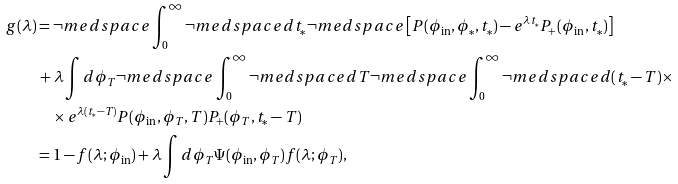<formula> <loc_0><loc_0><loc_500><loc_500>g ( \lambda ) & = \neg m e d s p a c e \int _ { 0 } ^ { \infty } \neg m e d s p a c e d t _ { * } \neg m e d s p a c e \left [ P ( \phi _ { \text {in} } , \phi _ { * } , t _ { * } ) - e ^ { \lambda t _ { * } } P _ { + } ( \phi _ { \text {in} } , t _ { * } ) \right ] \\ & \, + \lambda \int d \phi _ { T } \neg m e d s p a c e \int _ { 0 } ^ { \infty } \neg m e d s p a c e d T \neg m e d s p a c e \int _ { 0 } ^ { \infty } \neg m e d s p a c e d ( t _ { * } - T ) \times \\ & \quad \times e ^ { \lambda ( t _ { * } - T ) } P ( \phi _ { \text {in} } , \phi _ { T } , T ) P _ { + } ( \phi _ { T } , t _ { * } - T ) \\ & = 1 - f ( \lambda ; \phi _ { \text {in} } ) + \lambda \int d \phi _ { T } \Psi ( \phi _ { \text {in} } , \phi _ { T } ) f ( \lambda ; \phi _ { T } ) ,</formula> 